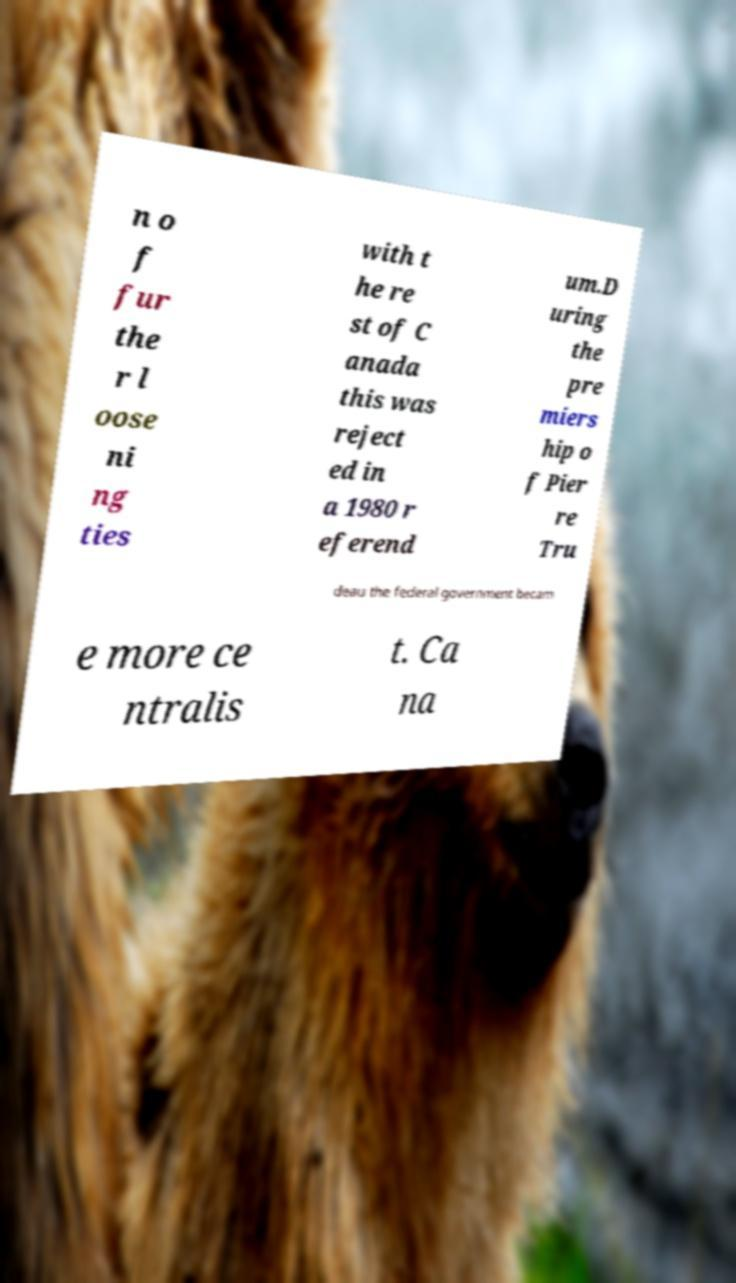Can you accurately transcribe the text from the provided image for me? n o f fur the r l oose ni ng ties with t he re st of C anada this was reject ed in a 1980 r eferend um.D uring the pre miers hip o f Pier re Tru deau the federal government becam e more ce ntralis t. Ca na 